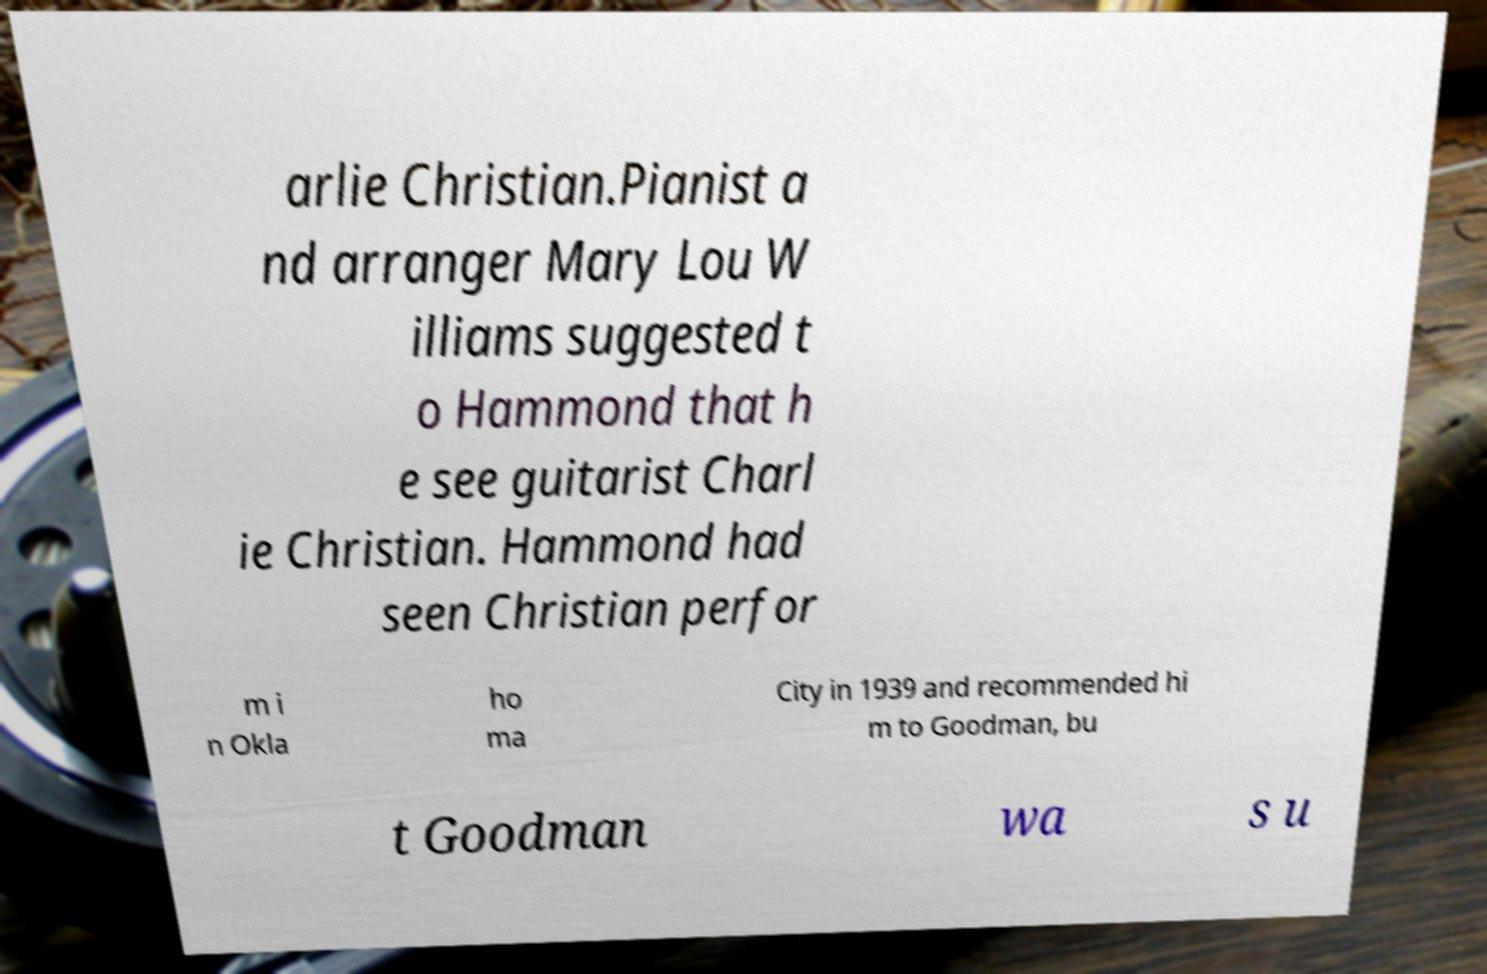Please identify and transcribe the text found in this image. arlie Christian.Pianist a nd arranger Mary Lou W illiams suggested t o Hammond that h e see guitarist Charl ie Christian. Hammond had seen Christian perfor m i n Okla ho ma City in 1939 and recommended hi m to Goodman, bu t Goodman wa s u 